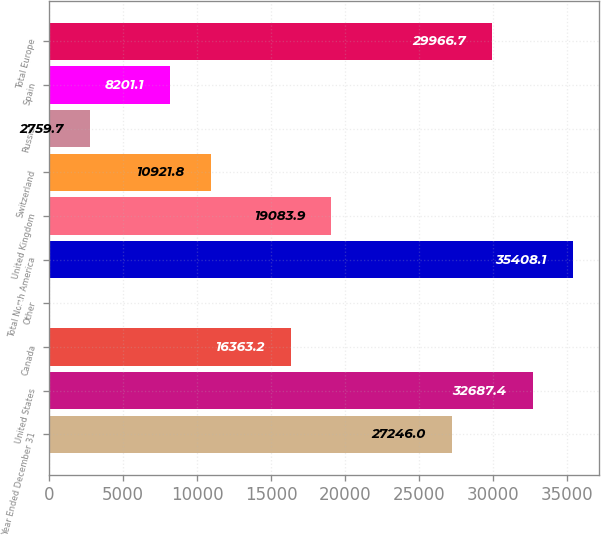<chart> <loc_0><loc_0><loc_500><loc_500><bar_chart><fcel>Year Ended December 31<fcel>United States<fcel>Canada<fcel>Other<fcel>Total North America<fcel>United Kingdom<fcel>Switzerland<fcel>Russia<fcel>Spain<fcel>Total Europe<nl><fcel>27246<fcel>32687.4<fcel>16363.2<fcel>39<fcel>35408.1<fcel>19083.9<fcel>10921.8<fcel>2759.7<fcel>8201.1<fcel>29966.7<nl></chart> 